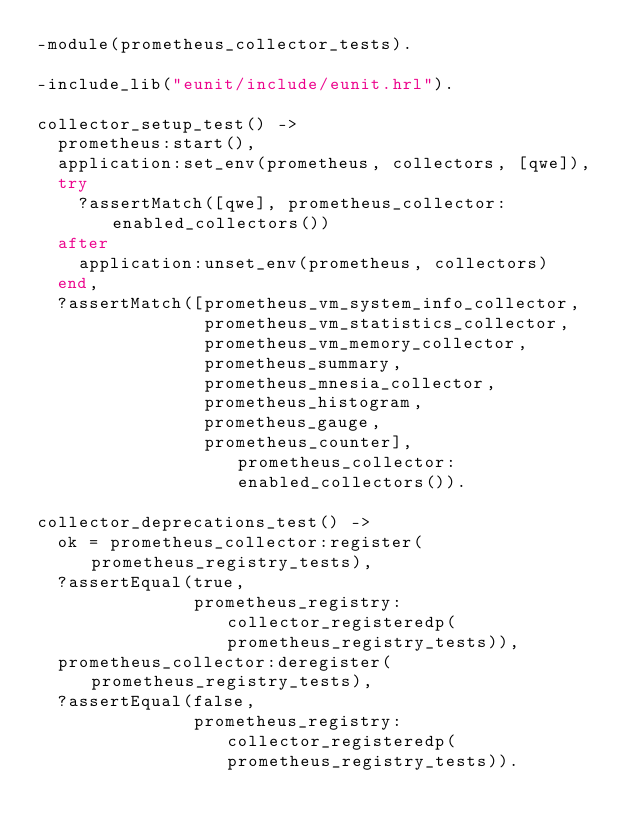Convert code to text. <code><loc_0><loc_0><loc_500><loc_500><_Erlang_>-module(prometheus_collector_tests).

-include_lib("eunit/include/eunit.hrl").

collector_setup_test() ->
  prometheus:start(),
  application:set_env(prometheus, collectors, [qwe]),
  try
    ?assertMatch([qwe], prometheus_collector:enabled_collectors())
  after
    application:unset_env(prometheus, collectors)
  end,
  ?assertMatch([prometheus_vm_system_info_collector,
                prometheus_vm_statistics_collector,
                prometheus_vm_memory_collector,
                prometheus_summary,
                prometheus_mnesia_collector,
                prometheus_histogram,
                prometheus_gauge,
                prometheus_counter], prometheus_collector:enabled_collectors()).

collector_deprecations_test() ->
  ok = prometheus_collector:register(prometheus_registry_tests),
  ?assertEqual(true,
               prometheus_registry:collector_registeredp(prometheus_registry_tests)),
  prometheus_collector:deregister(prometheus_registry_tests),
  ?assertEqual(false,
               prometheus_registry:collector_registeredp(prometheus_registry_tests)).
</code> 